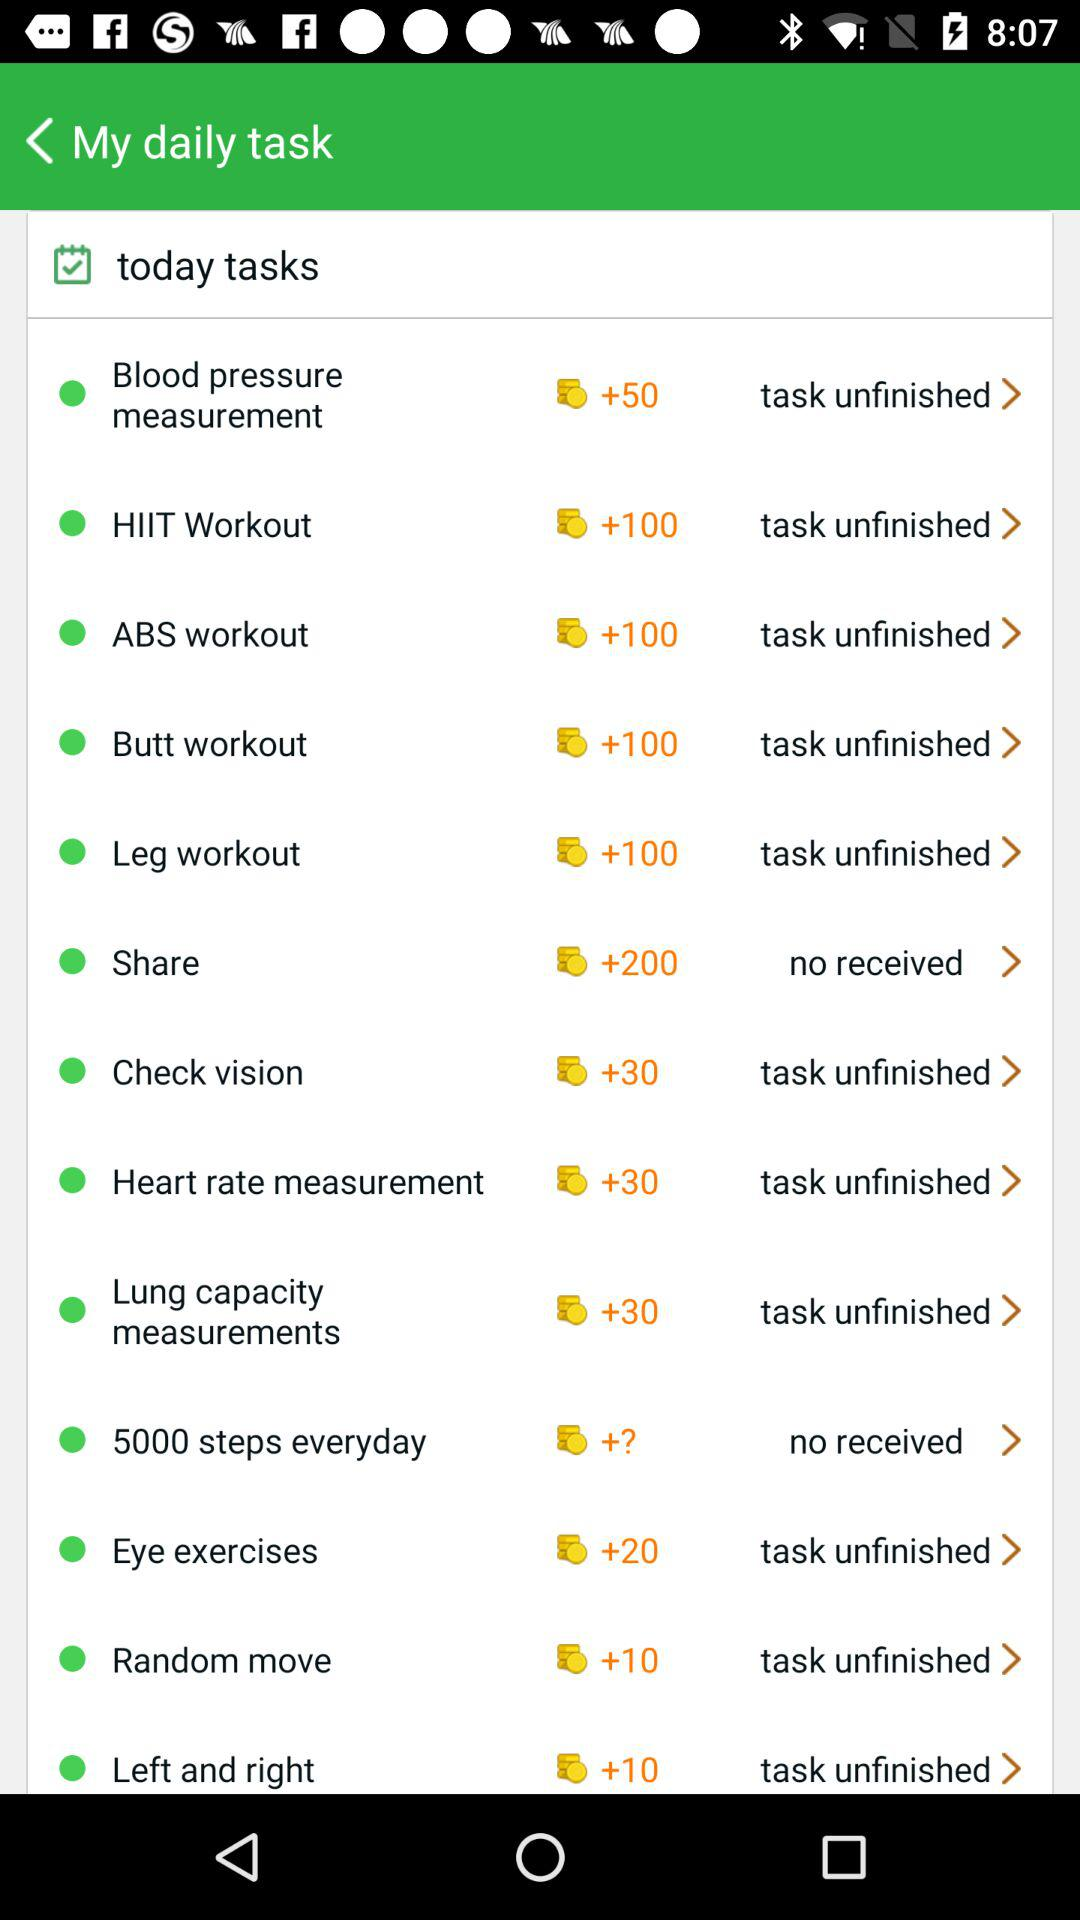What is the application name?
When the provided information is insufficient, respond with <no answer>. <no answer> 